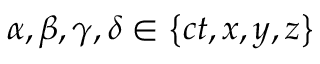<formula> <loc_0><loc_0><loc_500><loc_500>\alpha , \beta , \gamma , \delta \in \left \{ c t , x , y , z \right \}</formula> 